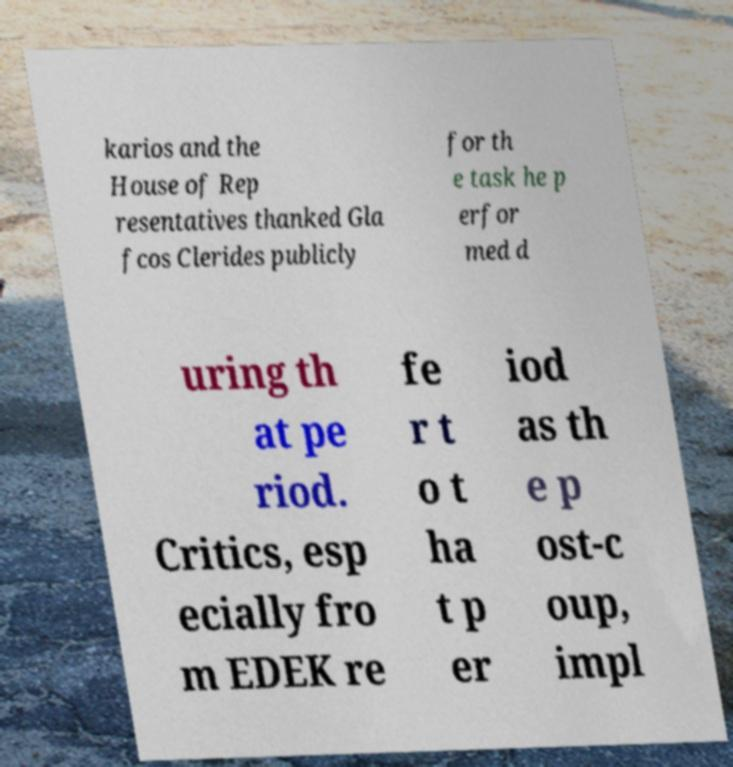Please identify and transcribe the text found in this image. karios and the House of Rep resentatives thanked Gla fcos Clerides publicly for th e task he p erfor med d uring th at pe riod. Critics, esp ecially fro m EDEK re fe r t o t ha t p er iod as th e p ost-c oup, impl 